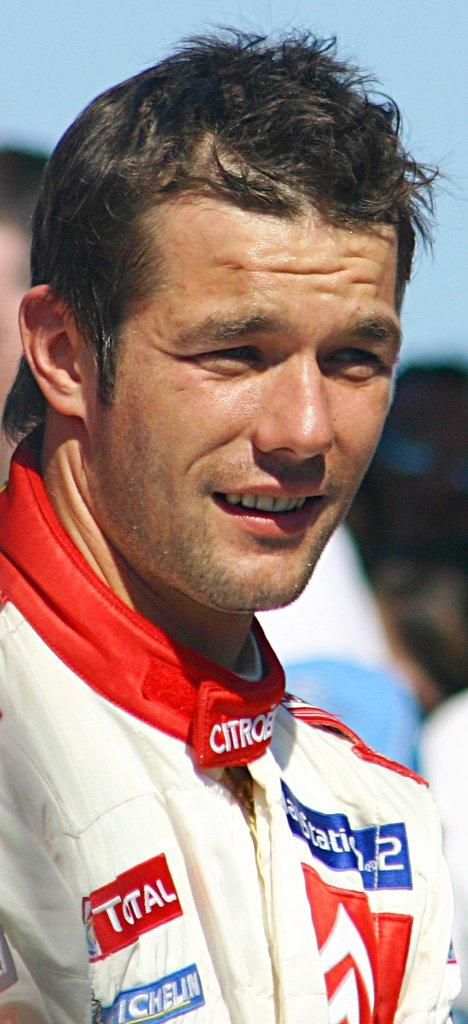<image>
Offer a succinct explanation of the picture presented. a man that has the word citro on their jacket 